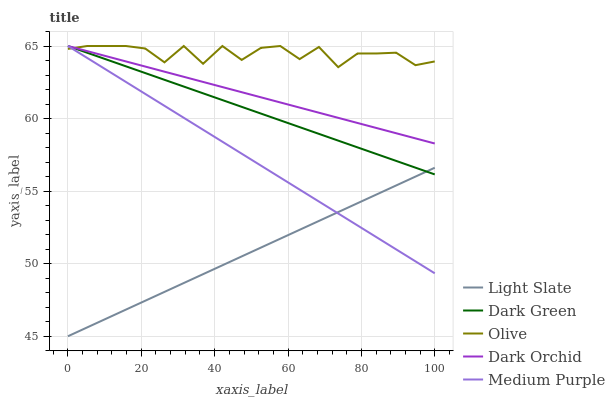Does Light Slate have the minimum area under the curve?
Answer yes or no. Yes. Does Olive have the maximum area under the curve?
Answer yes or no. Yes. Does Medium Purple have the minimum area under the curve?
Answer yes or no. No. Does Medium Purple have the maximum area under the curve?
Answer yes or no. No. Is Light Slate the smoothest?
Answer yes or no. Yes. Is Olive the roughest?
Answer yes or no. Yes. Is Medium Purple the smoothest?
Answer yes or no. No. Is Medium Purple the roughest?
Answer yes or no. No. Does Light Slate have the lowest value?
Answer yes or no. Yes. Does Medium Purple have the lowest value?
Answer yes or no. No. Does Dark Green have the highest value?
Answer yes or no. Yes. Is Light Slate less than Dark Orchid?
Answer yes or no. Yes. Is Olive greater than Light Slate?
Answer yes or no. Yes. Does Medium Purple intersect Dark Orchid?
Answer yes or no. Yes. Is Medium Purple less than Dark Orchid?
Answer yes or no. No. Is Medium Purple greater than Dark Orchid?
Answer yes or no. No. Does Light Slate intersect Dark Orchid?
Answer yes or no. No. 